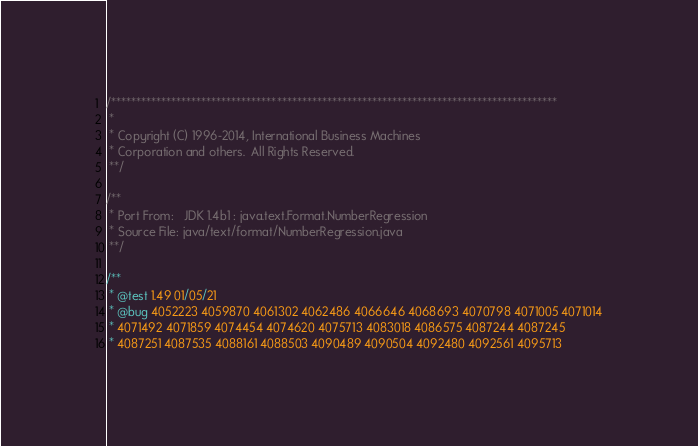<code> <loc_0><loc_0><loc_500><loc_500><_Java_>/*****************************************************************************************
 *
 * Copyright (C) 1996-2014, International Business Machines
 * Corporation and others.  All Rights Reserved.
 **/

/** 
 * Port From:   JDK 1.4b1 : java.text.Format.NumberRegression
 * Source File: java/text/format/NumberRegression.java
 **/
 
/**
 * @test 1.49 01/05/21
 * @bug 4052223 4059870 4061302 4062486 4066646 4068693 4070798 4071005 4071014
 * 4071492 4071859 4074454 4074620 4075713 4083018 4086575 4087244 4087245
 * 4087251 4087535 4088161 4088503 4090489 4090504 4092480 4092561 4095713</code> 